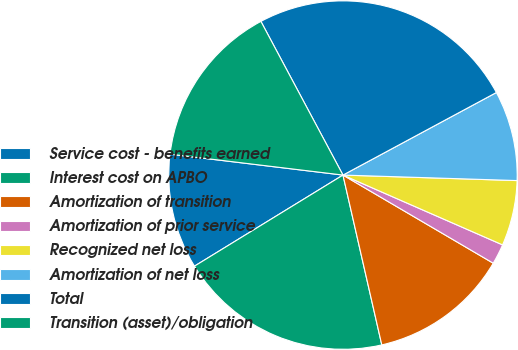<chart> <loc_0><loc_0><loc_500><loc_500><pie_chart><fcel>Service cost - benefits earned<fcel>Interest cost on APBO<fcel>Amortization of transition<fcel>Amortization of prior service<fcel>Recognized net loss<fcel>Amortization of net loss<fcel>Total<fcel>Transition (asset)/obligation<nl><fcel>10.67%<fcel>19.82%<fcel>12.98%<fcel>1.88%<fcel>6.06%<fcel>8.36%<fcel>24.95%<fcel>15.28%<nl></chart> 